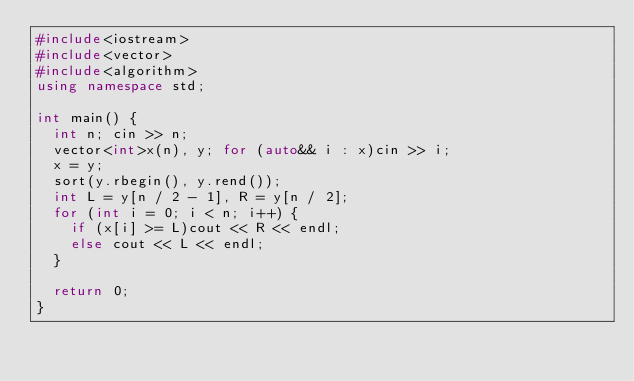<code> <loc_0><loc_0><loc_500><loc_500><_C++_>#include<iostream>
#include<vector>
#include<algorithm>
using namespace std;

int main() {
	int n; cin >> n;
	vector<int>x(n), y; for (auto&& i : x)cin >> i;
	x = y;
	sort(y.rbegin(), y.rend());
	int L = y[n / 2 - 1], R = y[n / 2];
	for (int i = 0; i < n; i++) {
		if (x[i] >= L)cout << R << endl;
		else cout << L << endl;
	}

	return 0;
}</code> 